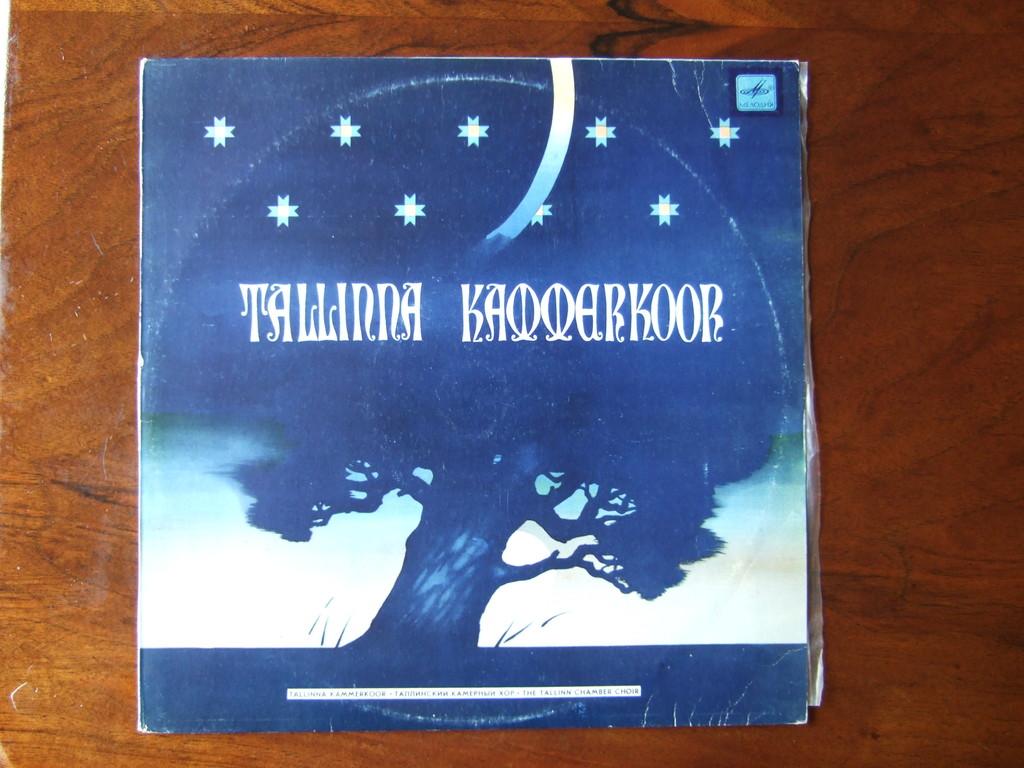What word can you make from the first three letters?
Your answer should be very brief. Tal. 